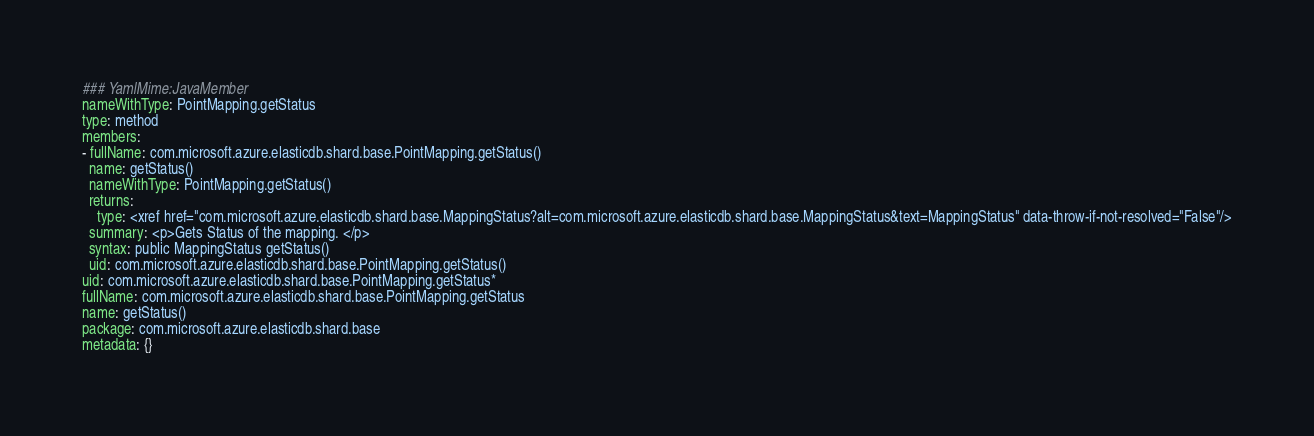Convert code to text. <code><loc_0><loc_0><loc_500><loc_500><_YAML_>### YamlMime:JavaMember
nameWithType: PointMapping.getStatus
type: method
members:
- fullName: com.microsoft.azure.elasticdb.shard.base.PointMapping.getStatus()
  name: getStatus()
  nameWithType: PointMapping.getStatus()
  returns:
    type: <xref href="com.microsoft.azure.elasticdb.shard.base.MappingStatus?alt=com.microsoft.azure.elasticdb.shard.base.MappingStatus&text=MappingStatus" data-throw-if-not-resolved="False"/>
  summary: <p>Gets Status of the mapping. </p>
  syntax: public MappingStatus getStatus()
  uid: com.microsoft.azure.elasticdb.shard.base.PointMapping.getStatus()
uid: com.microsoft.azure.elasticdb.shard.base.PointMapping.getStatus*
fullName: com.microsoft.azure.elasticdb.shard.base.PointMapping.getStatus
name: getStatus()
package: com.microsoft.azure.elasticdb.shard.base
metadata: {}
</code> 